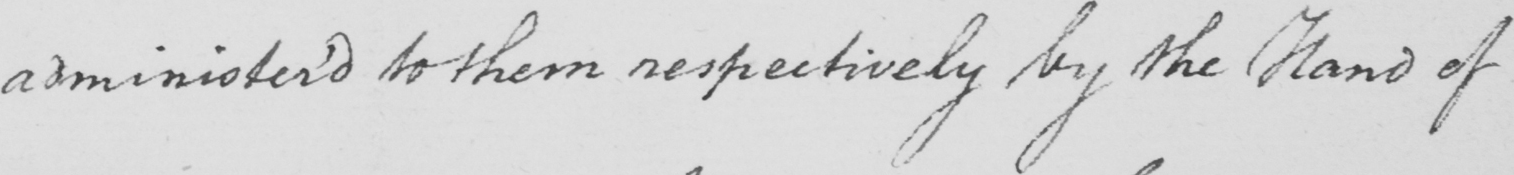Transcribe the text shown in this historical manuscript line. administer ' d to them respectively by the Hand of 